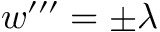Convert formula to latex. <formula><loc_0><loc_0><loc_500><loc_500>w ^ { \prime \prime \prime } = \pm \lambda</formula> 